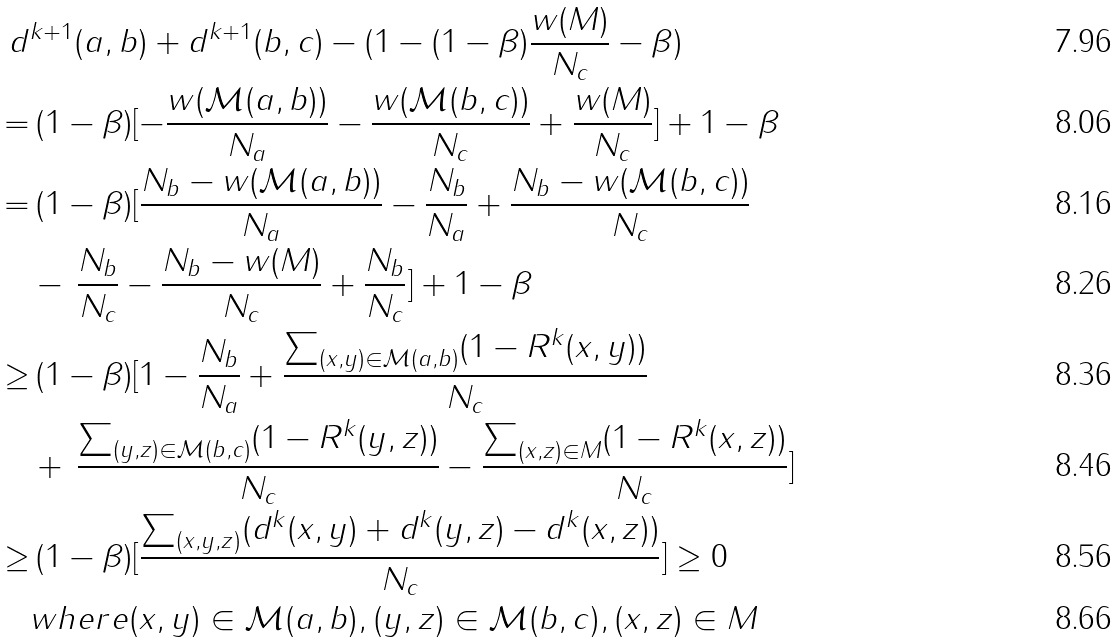<formula> <loc_0><loc_0><loc_500><loc_500>d & ^ { k + 1 } ( a , b ) + d ^ { k + 1 } ( b , c ) - ( 1 - ( 1 - \beta ) \frac { w ( M ) } { N _ { c } } - \beta ) \\ = & \, ( 1 - \beta ) [ - \frac { w ( \mathcal { M } ( a , b ) ) } { N _ { a } } - \frac { w ( \mathcal { M } ( b , c ) ) } { N _ { c } } + \frac { w ( M ) } { N _ { c } } ] + 1 - \beta \\ = & \, ( 1 - \beta ) [ \frac { N _ { b } - w ( \mathcal { M } ( a , b ) ) } { N _ { a } } - \frac { N _ { b } } { N _ { a } } + \frac { N _ { b } - w ( \mathcal { M } ( b , c ) ) } { N _ { c } } \\ & - \, \frac { N _ { b } } { N _ { c } } - \frac { N _ { b } - w ( M ) } { N _ { c } } + \frac { N _ { b } } { N _ { c } } ] + 1 - \beta \\ \geq & \, ( 1 - \beta ) [ 1 - \frac { N _ { b } } { N _ { a } } + \frac { \sum _ { ( x , y ) \in \mathcal { M } ( a , b ) } ( 1 - R ^ { k } ( x , y ) ) } { N _ { c } } \\ & + \, \frac { \sum _ { ( y , z ) \in \mathcal { M } ( b , c ) } ( 1 - R ^ { k } ( y , z ) ) } { N _ { c } } - \frac { \sum _ { ( x , z ) \in M } ( 1 - R ^ { k } ( x , z ) ) } { N _ { c } } ] \\ \geq & \, ( 1 - \beta ) [ \frac { \sum _ { ( x , y , z ) } ( d ^ { k } ( x , y ) + d ^ { k } ( y , z ) - d ^ { k } ( x , z ) ) } { N _ { c } } ] \geq 0 \\ & w h e r e ( x , y ) \in \mathcal { M } ( a , b ) , ( y , z ) \in \mathcal { M } ( b , c ) , ( x , z ) \in M</formula> 